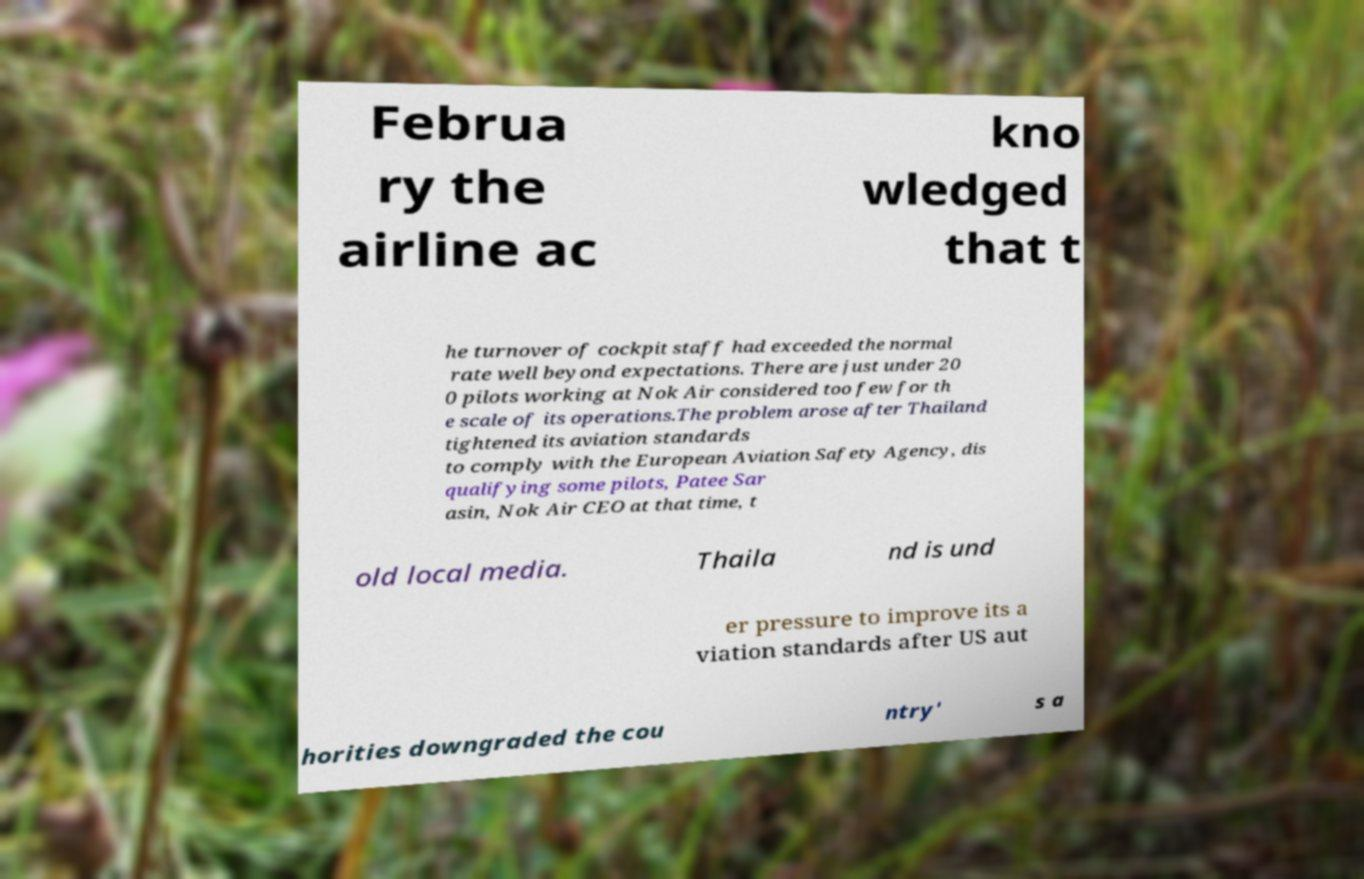What messages or text are displayed in this image? I need them in a readable, typed format. Februa ry the airline ac kno wledged that t he turnover of cockpit staff had exceeded the normal rate well beyond expectations. There are just under 20 0 pilots working at Nok Air considered too few for th e scale of its operations.The problem arose after Thailand tightened its aviation standards to comply with the European Aviation Safety Agency, dis qualifying some pilots, Patee Sar asin, Nok Air CEO at that time, t old local media. Thaila nd is und er pressure to improve its a viation standards after US aut horities downgraded the cou ntry' s a 